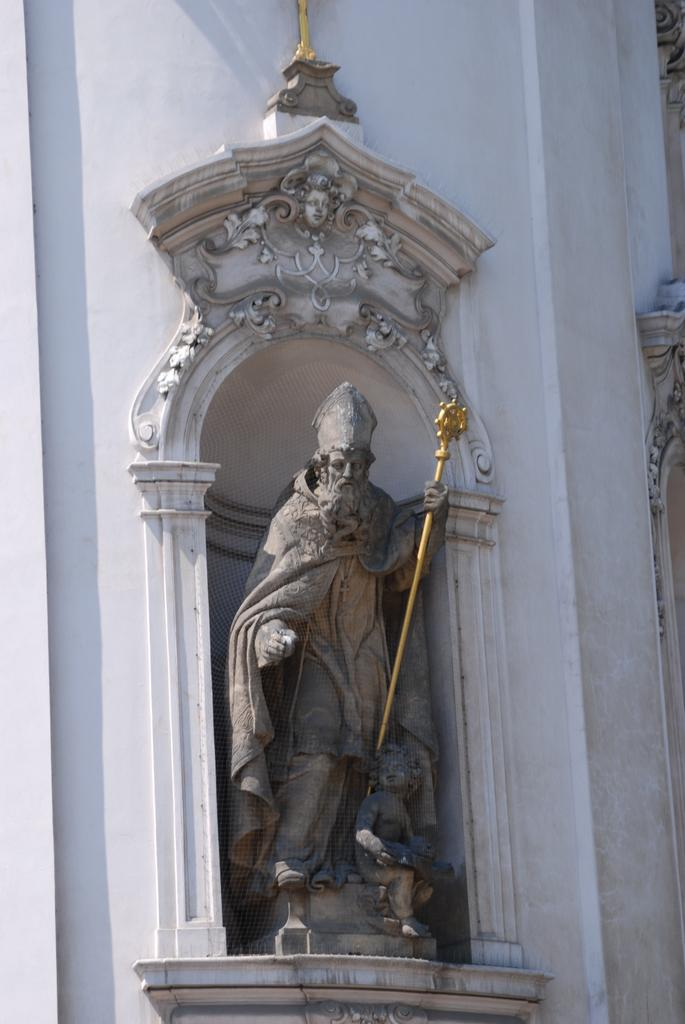What is the main subject of the image? There is a statue in the image. What is the statue depicting? The statue is of a person. What is the person holding in the statue? The person is holding a gold-colored object. Where is the statue located in the image? The statue is attached to a wall. What color is the wall that the statue is attached to? The wall is white in color. How many sheep can be seen grazing in the cemetery in the image? There is no cemetery or sheep present in the image; it features a statue attached to a white wall. 